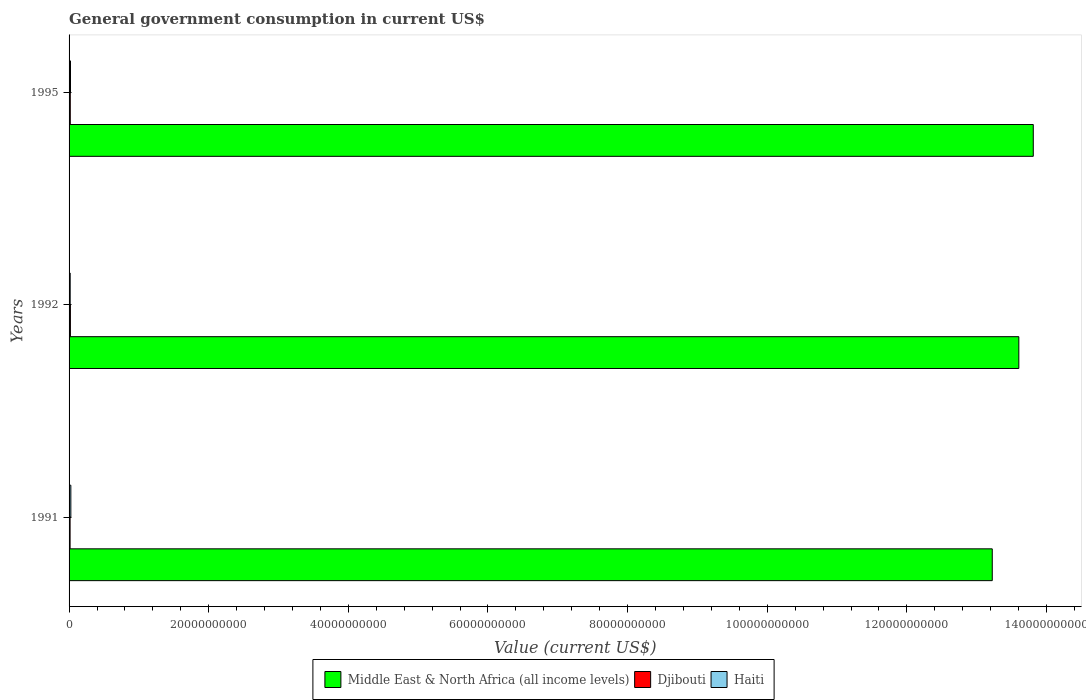In how many cases, is the number of bars for a given year not equal to the number of legend labels?
Give a very brief answer. 0. What is the government conusmption in Haiti in 1995?
Offer a terse response. 2.06e+08. Across all years, what is the maximum government conusmption in Djibouti?
Offer a very short reply. 1.92e+08. Across all years, what is the minimum government conusmption in Middle East & North Africa (all income levels)?
Give a very brief answer. 1.32e+11. In which year was the government conusmption in Djibouti minimum?
Make the answer very short. 1991. What is the total government conusmption in Haiti in the graph?
Offer a very short reply. 6.19e+08. What is the difference between the government conusmption in Middle East & North Africa (all income levels) in 1991 and that in 1995?
Offer a terse response. -5.88e+09. What is the difference between the government conusmption in Haiti in 1992 and the government conusmption in Djibouti in 1995?
Provide a short and direct response. -1.40e+07. What is the average government conusmption in Middle East & North Africa (all income levels) per year?
Your answer should be compact. 1.35e+11. In the year 1991, what is the difference between the government conusmption in Djibouti and government conusmption in Haiti?
Keep it short and to the point. -1.08e+08. In how many years, is the government conusmption in Middle East & North Africa (all income levels) greater than 124000000000 US$?
Your response must be concise. 3. What is the ratio of the government conusmption in Middle East & North Africa (all income levels) in 1992 to that in 1995?
Give a very brief answer. 0.99. What is the difference between the highest and the second highest government conusmption in Haiti?
Make the answer very short. 4.81e+07. What is the difference between the highest and the lowest government conusmption in Haiti?
Offer a terse response. 9.41e+07. In how many years, is the government conusmption in Haiti greater than the average government conusmption in Haiti taken over all years?
Your answer should be very brief. 1. Is the sum of the government conusmption in Haiti in 1991 and 1995 greater than the maximum government conusmption in Middle East & North Africa (all income levels) across all years?
Make the answer very short. No. What does the 2nd bar from the top in 1995 represents?
Your answer should be very brief. Djibouti. What does the 1st bar from the bottom in 1995 represents?
Your answer should be compact. Middle East & North Africa (all income levels). How many bars are there?
Keep it short and to the point. 9. Are the values on the major ticks of X-axis written in scientific E-notation?
Offer a terse response. No. Does the graph contain grids?
Make the answer very short. No. Where does the legend appear in the graph?
Give a very brief answer. Bottom center. How are the legend labels stacked?
Your response must be concise. Horizontal. What is the title of the graph?
Ensure brevity in your answer.  General government consumption in current US$. Does "Cote d'Ivoire" appear as one of the legend labels in the graph?
Provide a succinct answer. No. What is the label or title of the X-axis?
Offer a very short reply. Value (current US$). What is the label or title of the Y-axis?
Offer a very short reply. Years. What is the Value (current US$) of Middle East & North Africa (all income levels) in 1991?
Give a very brief answer. 1.32e+11. What is the Value (current US$) in Djibouti in 1991?
Your answer should be very brief. 1.46e+08. What is the Value (current US$) of Haiti in 1991?
Offer a terse response. 2.54e+08. What is the Value (current US$) of Middle East & North Africa (all income levels) in 1992?
Keep it short and to the point. 1.36e+11. What is the Value (current US$) of Djibouti in 1992?
Your answer should be compact. 1.92e+08. What is the Value (current US$) in Haiti in 1992?
Make the answer very short. 1.60e+08. What is the Value (current US$) of Middle East & North Africa (all income levels) in 1995?
Provide a short and direct response. 1.38e+11. What is the Value (current US$) in Djibouti in 1995?
Offer a very short reply. 1.74e+08. What is the Value (current US$) in Haiti in 1995?
Give a very brief answer. 2.06e+08. Across all years, what is the maximum Value (current US$) in Middle East & North Africa (all income levels)?
Provide a succinct answer. 1.38e+11. Across all years, what is the maximum Value (current US$) in Djibouti?
Your answer should be very brief. 1.92e+08. Across all years, what is the maximum Value (current US$) of Haiti?
Offer a very short reply. 2.54e+08. Across all years, what is the minimum Value (current US$) in Middle East & North Africa (all income levels)?
Make the answer very short. 1.32e+11. Across all years, what is the minimum Value (current US$) in Djibouti?
Provide a succinct answer. 1.46e+08. Across all years, what is the minimum Value (current US$) in Haiti?
Offer a very short reply. 1.60e+08. What is the total Value (current US$) in Middle East & North Africa (all income levels) in the graph?
Provide a succinct answer. 4.06e+11. What is the total Value (current US$) of Djibouti in the graph?
Offer a very short reply. 5.12e+08. What is the total Value (current US$) in Haiti in the graph?
Provide a succinct answer. 6.19e+08. What is the difference between the Value (current US$) in Middle East & North Africa (all income levels) in 1991 and that in 1992?
Provide a succinct answer. -3.81e+09. What is the difference between the Value (current US$) in Djibouti in 1991 and that in 1992?
Your response must be concise. -4.65e+07. What is the difference between the Value (current US$) in Haiti in 1991 and that in 1992?
Provide a succinct answer. 9.41e+07. What is the difference between the Value (current US$) in Middle East & North Africa (all income levels) in 1991 and that in 1995?
Make the answer very short. -5.88e+09. What is the difference between the Value (current US$) of Djibouti in 1991 and that in 1995?
Give a very brief answer. -2.80e+07. What is the difference between the Value (current US$) of Haiti in 1991 and that in 1995?
Keep it short and to the point. 4.81e+07. What is the difference between the Value (current US$) in Middle East & North Africa (all income levels) in 1992 and that in 1995?
Give a very brief answer. -2.07e+09. What is the difference between the Value (current US$) of Djibouti in 1992 and that in 1995?
Your answer should be very brief. 1.85e+07. What is the difference between the Value (current US$) of Haiti in 1992 and that in 1995?
Offer a terse response. -4.59e+07. What is the difference between the Value (current US$) in Middle East & North Africa (all income levels) in 1991 and the Value (current US$) in Djibouti in 1992?
Your answer should be compact. 1.32e+11. What is the difference between the Value (current US$) of Middle East & North Africa (all income levels) in 1991 and the Value (current US$) of Haiti in 1992?
Your answer should be compact. 1.32e+11. What is the difference between the Value (current US$) of Djibouti in 1991 and the Value (current US$) of Haiti in 1992?
Provide a short and direct response. -1.40e+07. What is the difference between the Value (current US$) in Middle East & North Africa (all income levels) in 1991 and the Value (current US$) in Djibouti in 1995?
Provide a succinct answer. 1.32e+11. What is the difference between the Value (current US$) in Middle East & North Africa (all income levels) in 1991 and the Value (current US$) in Haiti in 1995?
Ensure brevity in your answer.  1.32e+11. What is the difference between the Value (current US$) in Djibouti in 1991 and the Value (current US$) in Haiti in 1995?
Ensure brevity in your answer.  -5.99e+07. What is the difference between the Value (current US$) in Middle East & North Africa (all income levels) in 1992 and the Value (current US$) in Djibouti in 1995?
Make the answer very short. 1.36e+11. What is the difference between the Value (current US$) of Middle East & North Africa (all income levels) in 1992 and the Value (current US$) of Haiti in 1995?
Keep it short and to the point. 1.36e+11. What is the difference between the Value (current US$) in Djibouti in 1992 and the Value (current US$) in Haiti in 1995?
Offer a very short reply. -1.34e+07. What is the average Value (current US$) in Middle East & North Africa (all income levels) per year?
Offer a very short reply. 1.35e+11. What is the average Value (current US$) of Djibouti per year?
Your answer should be very brief. 1.71e+08. What is the average Value (current US$) of Haiti per year?
Offer a very short reply. 2.06e+08. In the year 1991, what is the difference between the Value (current US$) of Middle East & North Africa (all income levels) and Value (current US$) of Djibouti?
Provide a short and direct response. 1.32e+11. In the year 1991, what is the difference between the Value (current US$) of Middle East & North Africa (all income levels) and Value (current US$) of Haiti?
Provide a succinct answer. 1.32e+11. In the year 1991, what is the difference between the Value (current US$) in Djibouti and Value (current US$) in Haiti?
Your response must be concise. -1.08e+08. In the year 1992, what is the difference between the Value (current US$) of Middle East & North Africa (all income levels) and Value (current US$) of Djibouti?
Give a very brief answer. 1.36e+11. In the year 1992, what is the difference between the Value (current US$) of Middle East & North Africa (all income levels) and Value (current US$) of Haiti?
Make the answer very short. 1.36e+11. In the year 1992, what is the difference between the Value (current US$) in Djibouti and Value (current US$) in Haiti?
Make the answer very short. 3.25e+07. In the year 1995, what is the difference between the Value (current US$) in Middle East & North Africa (all income levels) and Value (current US$) in Djibouti?
Provide a short and direct response. 1.38e+11. In the year 1995, what is the difference between the Value (current US$) of Middle East & North Africa (all income levels) and Value (current US$) of Haiti?
Keep it short and to the point. 1.38e+11. In the year 1995, what is the difference between the Value (current US$) in Djibouti and Value (current US$) in Haiti?
Your answer should be compact. -3.19e+07. What is the ratio of the Value (current US$) of Middle East & North Africa (all income levels) in 1991 to that in 1992?
Give a very brief answer. 0.97. What is the ratio of the Value (current US$) in Djibouti in 1991 to that in 1992?
Give a very brief answer. 0.76. What is the ratio of the Value (current US$) in Haiti in 1991 to that in 1992?
Give a very brief answer. 1.59. What is the ratio of the Value (current US$) in Middle East & North Africa (all income levels) in 1991 to that in 1995?
Give a very brief answer. 0.96. What is the ratio of the Value (current US$) in Djibouti in 1991 to that in 1995?
Ensure brevity in your answer.  0.84. What is the ratio of the Value (current US$) in Haiti in 1991 to that in 1995?
Your answer should be very brief. 1.23. What is the ratio of the Value (current US$) of Middle East & North Africa (all income levels) in 1992 to that in 1995?
Offer a very short reply. 0.98. What is the ratio of the Value (current US$) in Djibouti in 1992 to that in 1995?
Provide a succinct answer. 1.11. What is the ratio of the Value (current US$) in Haiti in 1992 to that in 1995?
Provide a short and direct response. 0.78. What is the difference between the highest and the second highest Value (current US$) in Middle East & North Africa (all income levels)?
Give a very brief answer. 2.07e+09. What is the difference between the highest and the second highest Value (current US$) of Djibouti?
Give a very brief answer. 1.85e+07. What is the difference between the highest and the second highest Value (current US$) in Haiti?
Make the answer very short. 4.81e+07. What is the difference between the highest and the lowest Value (current US$) in Middle East & North Africa (all income levels)?
Ensure brevity in your answer.  5.88e+09. What is the difference between the highest and the lowest Value (current US$) of Djibouti?
Ensure brevity in your answer.  4.65e+07. What is the difference between the highest and the lowest Value (current US$) in Haiti?
Provide a succinct answer. 9.41e+07. 